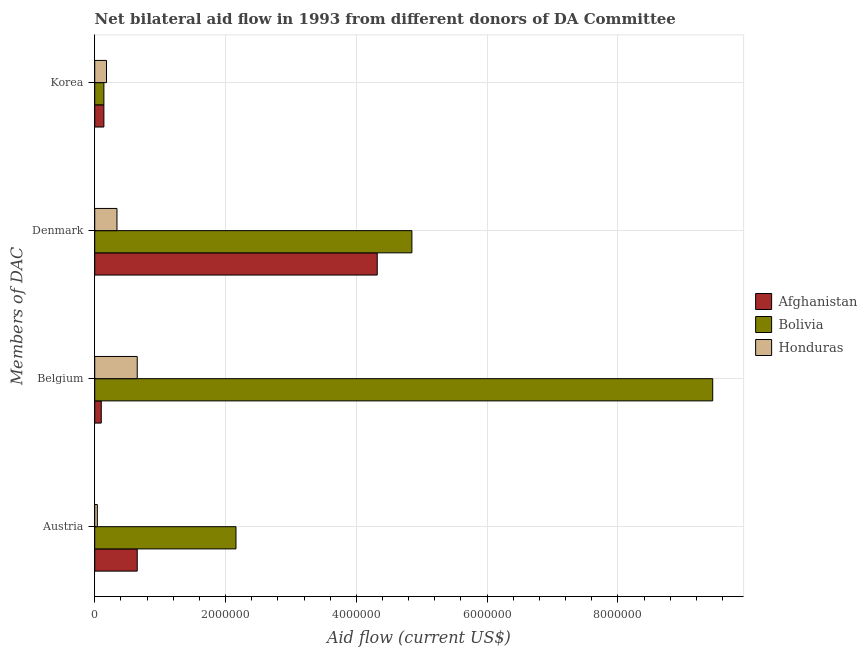How many groups of bars are there?
Your response must be concise. 4. What is the label of the 4th group of bars from the top?
Give a very brief answer. Austria. What is the amount of aid given by belgium in Afghanistan?
Ensure brevity in your answer.  1.00e+05. Across all countries, what is the maximum amount of aid given by denmark?
Make the answer very short. 4.85e+06. Across all countries, what is the minimum amount of aid given by denmark?
Provide a short and direct response. 3.40e+05. In which country was the amount of aid given by belgium maximum?
Provide a succinct answer. Bolivia. In which country was the amount of aid given by korea minimum?
Your answer should be very brief. Afghanistan. What is the total amount of aid given by korea in the graph?
Provide a succinct answer. 4.60e+05. What is the difference between the amount of aid given by austria in Bolivia and that in Honduras?
Provide a short and direct response. 2.12e+06. What is the difference between the amount of aid given by belgium in Bolivia and the amount of aid given by austria in Afghanistan?
Ensure brevity in your answer.  8.80e+06. What is the average amount of aid given by korea per country?
Provide a succinct answer. 1.53e+05. What is the difference between the amount of aid given by belgium and amount of aid given by korea in Bolivia?
Keep it short and to the point. 9.31e+06. What is the ratio of the amount of aid given by denmark in Honduras to that in Bolivia?
Provide a short and direct response. 0.07. Is the amount of aid given by austria in Bolivia less than that in Honduras?
Your response must be concise. No. Is the difference between the amount of aid given by belgium in Bolivia and Afghanistan greater than the difference between the amount of aid given by denmark in Bolivia and Afghanistan?
Give a very brief answer. Yes. What is the difference between the highest and the lowest amount of aid given by korea?
Your answer should be very brief. 4.00e+04. In how many countries, is the amount of aid given by denmark greater than the average amount of aid given by denmark taken over all countries?
Your response must be concise. 2. Is it the case that in every country, the sum of the amount of aid given by austria and amount of aid given by korea is greater than the sum of amount of aid given by denmark and amount of aid given by belgium?
Ensure brevity in your answer.  No. What does the 3rd bar from the top in Korea represents?
Offer a very short reply. Afghanistan. What does the 1st bar from the bottom in Austria represents?
Make the answer very short. Afghanistan. Are the values on the major ticks of X-axis written in scientific E-notation?
Make the answer very short. No. Does the graph contain any zero values?
Offer a terse response. No. How many legend labels are there?
Offer a terse response. 3. What is the title of the graph?
Ensure brevity in your answer.  Net bilateral aid flow in 1993 from different donors of DA Committee. What is the label or title of the Y-axis?
Ensure brevity in your answer.  Members of DAC. What is the Aid flow (current US$) in Afghanistan in Austria?
Ensure brevity in your answer.  6.50e+05. What is the Aid flow (current US$) in Bolivia in Austria?
Your answer should be compact. 2.16e+06. What is the Aid flow (current US$) of Honduras in Austria?
Your answer should be very brief. 4.00e+04. What is the Aid flow (current US$) in Afghanistan in Belgium?
Make the answer very short. 1.00e+05. What is the Aid flow (current US$) in Bolivia in Belgium?
Ensure brevity in your answer.  9.45e+06. What is the Aid flow (current US$) in Honduras in Belgium?
Offer a terse response. 6.50e+05. What is the Aid flow (current US$) in Afghanistan in Denmark?
Provide a succinct answer. 4.32e+06. What is the Aid flow (current US$) in Bolivia in Denmark?
Provide a succinct answer. 4.85e+06. What is the Aid flow (current US$) of Afghanistan in Korea?
Provide a short and direct response. 1.40e+05. What is the Aid flow (current US$) of Honduras in Korea?
Your response must be concise. 1.80e+05. Across all Members of DAC, what is the maximum Aid flow (current US$) of Afghanistan?
Your response must be concise. 4.32e+06. Across all Members of DAC, what is the maximum Aid flow (current US$) of Bolivia?
Your answer should be very brief. 9.45e+06. Across all Members of DAC, what is the maximum Aid flow (current US$) in Honduras?
Give a very brief answer. 6.50e+05. Across all Members of DAC, what is the minimum Aid flow (current US$) in Afghanistan?
Provide a succinct answer. 1.00e+05. What is the total Aid flow (current US$) of Afghanistan in the graph?
Provide a succinct answer. 5.21e+06. What is the total Aid flow (current US$) in Bolivia in the graph?
Provide a succinct answer. 1.66e+07. What is the total Aid flow (current US$) of Honduras in the graph?
Keep it short and to the point. 1.21e+06. What is the difference between the Aid flow (current US$) of Afghanistan in Austria and that in Belgium?
Make the answer very short. 5.50e+05. What is the difference between the Aid flow (current US$) of Bolivia in Austria and that in Belgium?
Ensure brevity in your answer.  -7.29e+06. What is the difference between the Aid flow (current US$) in Honduras in Austria and that in Belgium?
Your response must be concise. -6.10e+05. What is the difference between the Aid flow (current US$) in Afghanistan in Austria and that in Denmark?
Keep it short and to the point. -3.67e+06. What is the difference between the Aid flow (current US$) of Bolivia in Austria and that in Denmark?
Your answer should be compact. -2.69e+06. What is the difference between the Aid flow (current US$) of Honduras in Austria and that in Denmark?
Offer a very short reply. -3.00e+05. What is the difference between the Aid flow (current US$) of Afghanistan in Austria and that in Korea?
Your answer should be very brief. 5.10e+05. What is the difference between the Aid flow (current US$) of Bolivia in Austria and that in Korea?
Offer a very short reply. 2.02e+06. What is the difference between the Aid flow (current US$) in Honduras in Austria and that in Korea?
Your answer should be compact. -1.40e+05. What is the difference between the Aid flow (current US$) of Afghanistan in Belgium and that in Denmark?
Provide a succinct answer. -4.22e+06. What is the difference between the Aid flow (current US$) of Bolivia in Belgium and that in Denmark?
Provide a short and direct response. 4.60e+06. What is the difference between the Aid flow (current US$) of Honduras in Belgium and that in Denmark?
Keep it short and to the point. 3.10e+05. What is the difference between the Aid flow (current US$) in Afghanistan in Belgium and that in Korea?
Your answer should be compact. -4.00e+04. What is the difference between the Aid flow (current US$) in Bolivia in Belgium and that in Korea?
Give a very brief answer. 9.31e+06. What is the difference between the Aid flow (current US$) of Afghanistan in Denmark and that in Korea?
Your response must be concise. 4.18e+06. What is the difference between the Aid flow (current US$) in Bolivia in Denmark and that in Korea?
Ensure brevity in your answer.  4.71e+06. What is the difference between the Aid flow (current US$) of Honduras in Denmark and that in Korea?
Offer a very short reply. 1.60e+05. What is the difference between the Aid flow (current US$) in Afghanistan in Austria and the Aid flow (current US$) in Bolivia in Belgium?
Provide a short and direct response. -8.80e+06. What is the difference between the Aid flow (current US$) in Bolivia in Austria and the Aid flow (current US$) in Honduras in Belgium?
Keep it short and to the point. 1.51e+06. What is the difference between the Aid flow (current US$) in Afghanistan in Austria and the Aid flow (current US$) in Bolivia in Denmark?
Your response must be concise. -4.20e+06. What is the difference between the Aid flow (current US$) in Bolivia in Austria and the Aid flow (current US$) in Honduras in Denmark?
Offer a very short reply. 1.82e+06. What is the difference between the Aid flow (current US$) in Afghanistan in Austria and the Aid flow (current US$) in Bolivia in Korea?
Keep it short and to the point. 5.10e+05. What is the difference between the Aid flow (current US$) of Afghanistan in Austria and the Aid flow (current US$) of Honduras in Korea?
Keep it short and to the point. 4.70e+05. What is the difference between the Aid flow (current US$) in Bolivia in Austria and the Aid flow (current US$) in Honduras in Korea?
Provide a succinct answer. 1.98e+06. What is the difference between the Aid flow (current US$) in Afghanistan in Belgium and the Aid flow (current US$) in Bolivia in Denmark?
Ensure brevity in your answer.  -4.75e+06. What is the difference between the Aid flow (current US$) in Bolivia in Belgium and the Aid flow (current US$) in Honduras in Denmark?
Your response must be concise. 9.11e+06. What is the difference between the Aid flow (current US$) of Afghanistan in Belgium and the Aid flow (current US$) of Honduras in Korea?
Give a very brief answer. -8.00e+04. What is the difference between the Aid flow (current US$) of Bolivia in Belgium and the Aid flow (current US$) of Honduras in Korea?
Offer a very short reply. 9.27e+06. What is the difference between the Aid flow (current US$) in Afghanistan in Denmark and the Aid flow (current US$) in Bolivia in Korea?
Your answer should be very brief. 4.18e+06. What is the difference between the Aid flow (current US$) in Afghanistan in Denmark and the Aid flow (current US$) in Honduras in Korea?
Your answer should be compact. 4.14e+06. What is the difference between the Aid flow (current US$) in Bolivia in Denmark and the Aid flow (current US$) in Honduras in Korea?
Offer a terse response. 4.67e+06. What is the average Aid flow (current US$) of Afghanistan per Members of DAC?
Provide a short and direct response. 1.30e+06. What is the average Aid flow (current US$) of Bolivia per Members of DAC?
Give a very brief answer. 4.15e+06. What is the average Aid flow (current US$) of Honduras per Members of DAC?
Keep it short and to the point. 3.02e+05. What is the difference between the Aid flow (current US$) of Afghanistan and Aid flow (current US$) of Bolivia in Austria?
Your response must be concise. -1.51e+06. What is the difference between the Aid flow (current US$) in Afghanistan and Aid flow (current US$) in Honduras in Austria?
Ensure brevity in your answer.  6.10e+05. What is the difference between the Aid flow (current US$) in Bolivia and Aid flow (current US$) in Honduras in Austria?
Your answer should be very brief. 2.12e+06. What is the difference between the Aid flow (current US$) of Afghanistan and Aid flow (current US$) of Bolivia in Belgium?
Your answer should be compact. -9.35e+06. What is the difference between the Aid flow (current US$) in Afghanistan and Aid flow (current US$) in Honduras in Belgium?
Give a very brief answer. -5.50e+05. What is the difference between the Aid flow (current US$) in Bolivia and Aid flow (current US$) in Honduras in Belgium?
Your response must be concise. 8.80e+06. What is the difference between the Aid flow (current US$) in Afghanistan and Aid flow (current US$) in Bolivia in Denmark?
Your answer should be very brief. -5.30e+05. What is the difference between the Aid flow (current US$) in Afghanistan and Aid flow (current US$) in Honduras in Denmark?
Ensure brevity in your answer.  3.98e+06. What is the difference between the Aid flow (current US$) of Bolivia and Aid flow (current US$) of Honduras in Denmark?
Your answer should be very brief. 4.51e+06. What is the difference between the Aid flow (current US$) in Afghanistan and Aid flow (current US$) in Bolivia in Korea?
Provide a short and direct response. 0. What is the difference between the Aid flow (current US$) of Bolivia and Aid flow (current US$) of Honduras in Korea?
Your answer should be very brief. -4.00e+04. What is the ratio of the Aid flow (current US$) in Afghanistan in Austria to that in Belgium?
Your answer should be compact. 6.5. What is the ratio of the Aid flow (current US$) of Bolivia in Austria to that in Belgium?
Give a very brief answer. 0.23. What is the ratio of the Aid flow (current US$) of Honduras in Austria to that in Belgium?
Provide a short and direct response. 0.06. What is the ratio of the Aid flow (current US$) in Afghanistan in Austria to that in Denmark?
Offer a terse response. 0.15. What is the ratio of the Aid flow (current US$) of Bolivia in Austria to that in Denmark?
Your answer should be very brief. 0.45. What is the ratio of the Aid flow (current US$) of Honduras in Austria to that in Denmark?
Your response must be concise. 0.12. What is the ratio of the Aid flow (current US$) of Afghanistan in Austria to that in Korea?
Your response must be concise. 4.64. What is the ratio of the Aid flow (current US$) of Bolivia in Austria to that in Korea?
Ensure brevity in your answer.  15.43. What is the ratio of the Aid flow (current US$) in Honduras in Austria to that in Korea?
Offer a terse response. 0.22. What is the ratio of the Aid flow (current US$) in Afghanistan in Belgium to that in Denmark?
Offer a very short reply. 0.02. What is the ratio of the Aid flow (current US$) of Bolivia in Belgium to that in Denmark?
Your response must be concise. 1.95. What is the ratio of the Aid flow (current US$) of Honduras in Belgium to that in Denmark?
Provide a short and direct response. 1.91. What is the ratio of the Aid flow (current US$) of Bolivia in Belgium to that in Korea?
Your answer should be very brief. 67.5. What is the ratio of the Aid flow (current US$) in Honduras in Belgium to that in Korea?
Make the answer very short. 3.61. What is the ratio of the Aid flow (current US$) in Afghanistan in Denmark to that in Korea?
Your response must be concise. 30.86. What is the ratio of the Aid flow (current US$) of Bolivia in Denmark to that in Korea?
Your answer should be compact. 34.64. What is the ratio of the Aid flow (current US$) of Honduras in Denmark to that in Korea?
Offer a very short reply. 1.89. What is the difference between the highest and the second highest Aid flow (current US$) in Afghanistan?
Make the answer very short. 3.67e+06. What is the difference between the highest and the second highest Aid flow (current US$) in Bolivia?
Provide a short and direct response. 4.60e+06. What is the difference between the highest and the second highest Aid flow (current US$) of Honduras?
Ensure brevity in your answer.  3.10e+05. What is the difference between the highest and the lowest Aid flow (current US$) in Afghanistan?
Give a very brief answer. 4.22e+06. What is the difference between the highest and the lowest Aid flow (current US$) in Bolivia?
Your response must be concise. 9.31e+06. What is the difference between the highest and the lowest Aid flow (current US$) in Honduras?
Provide a succinct answer. 6.10e+05. 